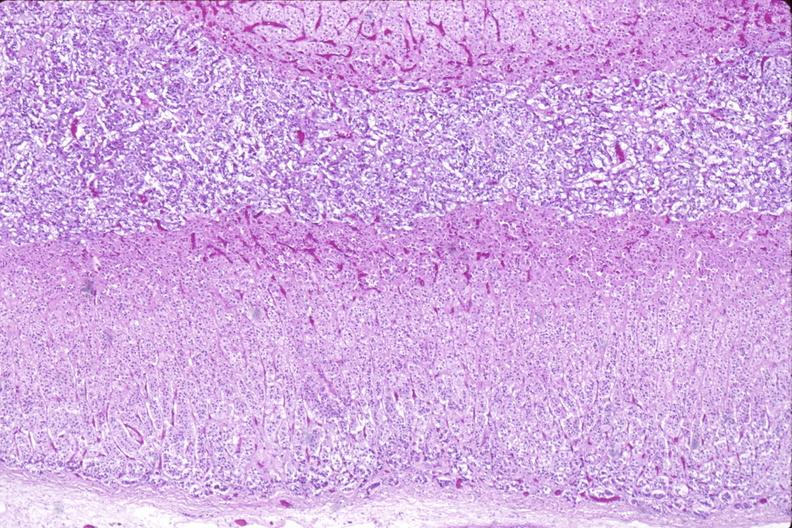where is this part in the figure?
Answer the question using a single word or phrase. Endocrine system 